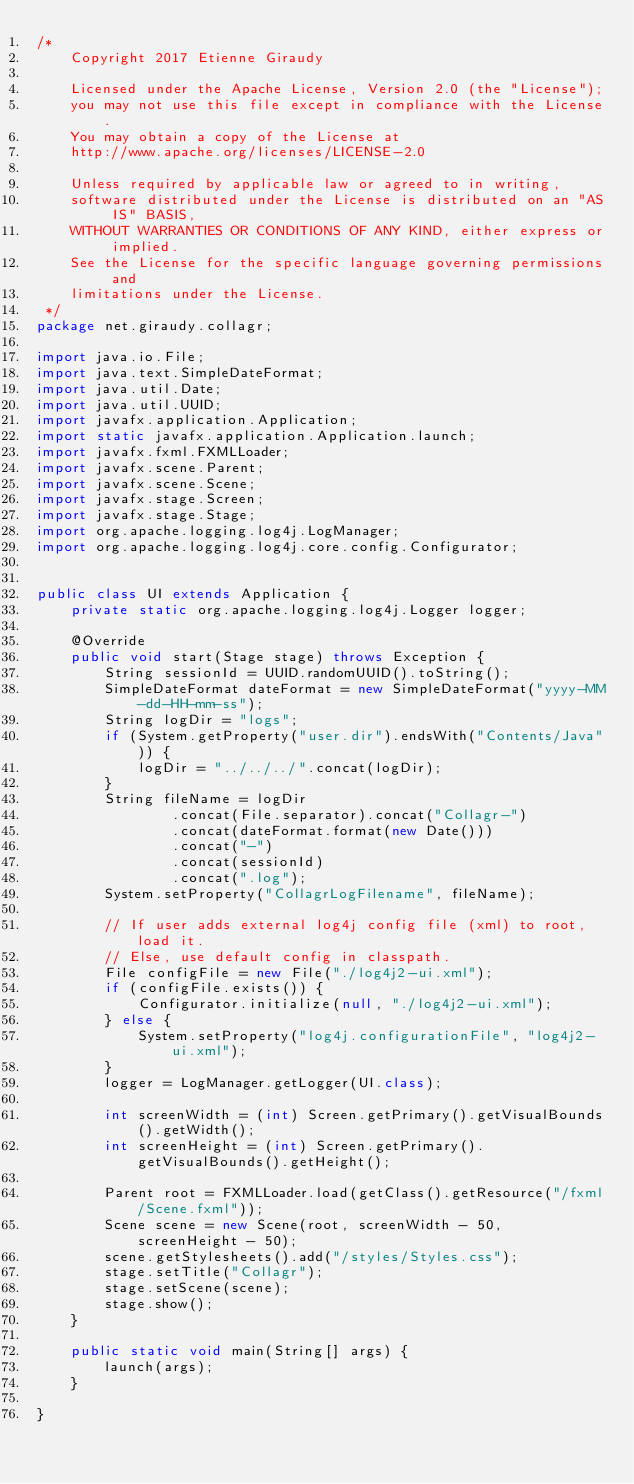Convert code to text. <code><loc_0><loc_0><loc_500><loc_500><_Java_>/*
    Copyright 2017 Etienne Giraudy

    Licensed under the Apache License, Version 2.0 (the "License"); 
    you may not use this file except in compliance with the License. 
    You may obtain a copy of the License at
    http://www.apache.org/licenses/LICENSE-2.0

    Unless required by applicable law or agreed to in writing, 
    software distributed under the License is distributed on an "AS IS" BASIS, 
    WITHOUT WARRANTIES OR CONDITIONS OF ANY KIND, either express or implied. 
    See the License for the specific language governing permissions and 
    limitations under the License.
 */
package net.giraudy.collagr;

import java.io.File;
import java.text.SimpleDateFormat;
import java.util.Date;
import java.util.UUID;
import javafx.application.Application;
import static javafx.application.Application.launch;
import javafx.fxml.FXMLLoader;
import javafx.scene.Parent;
import javafx.scene.Scene;
import javafx.stage.Screen;
import javafx.stage.Stage;
import org.apache.logging.log4j.LogManager;
import org.apache.logging.log4j.core.config.Configurator;


public class UI extends Application {
    private static org.apache.logging.log4j.Logger logger;

    @Override
    public void start(Stage stage) throws Exception {
        String sessionId = UUID.randomUUID().toString();
        SimpleDateFormat dateFormat = new SimpleDateFormat("yyyy-MM-dd-HH-mm-ss");
        String logDir = "logs";
        if (System.getProperty("user.dir").endsWith("Contents/Java")) {
            logDir = "../../../".concat(logDir);
        }
        String fileName = logDir
                .concat(File.separator).concat("Collagr-")
                .concat(dateFormat.format(new Date()))
                .concat("-")
                .concat(sessionId)
                .concat(".log");
        System.setProperty("CollagrLogFilename", fileName);

        // If user adds external log4j config file (xml) to root, load it.
        // Else, use default config in classpath.
        File configFile = new File("./log4j2-ui.xml");
        if (configFile.exists()) {
            Configurator.initialize(null, "./log4j2-ui.xml");
        } else {
            System.setProperty("log4j.configurationFile", "log4j2-ui.xml");
        }
        logger = LogManager.getLogger(UI.class);
                        
        int screenWidth = (int) Screen.getPrimary().getVisualBounds().getWidth();
        int screenHeight = (int) Screen.getPrimary().getVisualBounds().getHeight();

        Parent root = FXMLLoader.load(getClass().getResource("/fxml/Scene.fxml"));
        Scene scene = new Scene(root, screenWidth - 50, screenHeight - 50);
        scene.getStylesheets().add("/styles/Styles.css");
        stage.setTitle("Collagr");
        stage.setScene(scene);
        stage.show();
    }

    public static void main(String[] args) {
        launch(args);
    }

}
</code> 